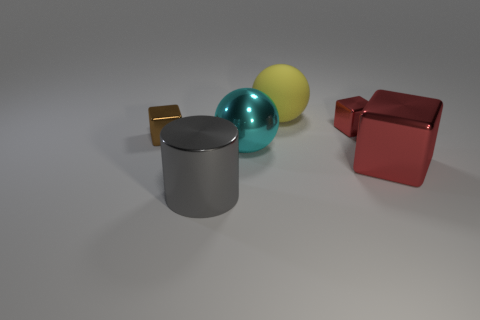Add 1 small red things. How many objects exist? 7 Subtract all cylinders. How many objects are left? 5 Subtract all large blue cylinders. Subtract all tiny red blocks. How many objects are left? 5 Add 1 big cyan metal balls. How many big cyan metal balls are left? 2 Add 3 metal things. How many metal things exist? 8 Subtract 0 brown cylinders. How many objects are left? 6 